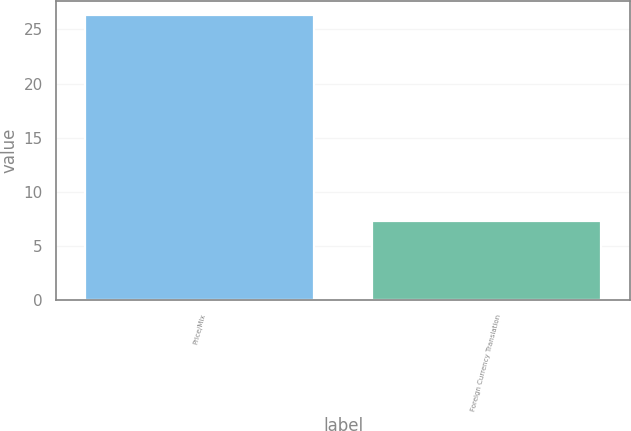Convert chart to OTSL. <chart><loc_0><loc_0><loc_500><loc_500><bar_chart><fcel>Price/Mix<fcel>Foreign Currency Translation<nl><fcel>26.3<fcel>7.3<nl></chart> 